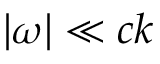Convert formula to latex. <formula><loc_0><loc_0><loc_500><loc_500>| \omega | \ll c k</formula> 